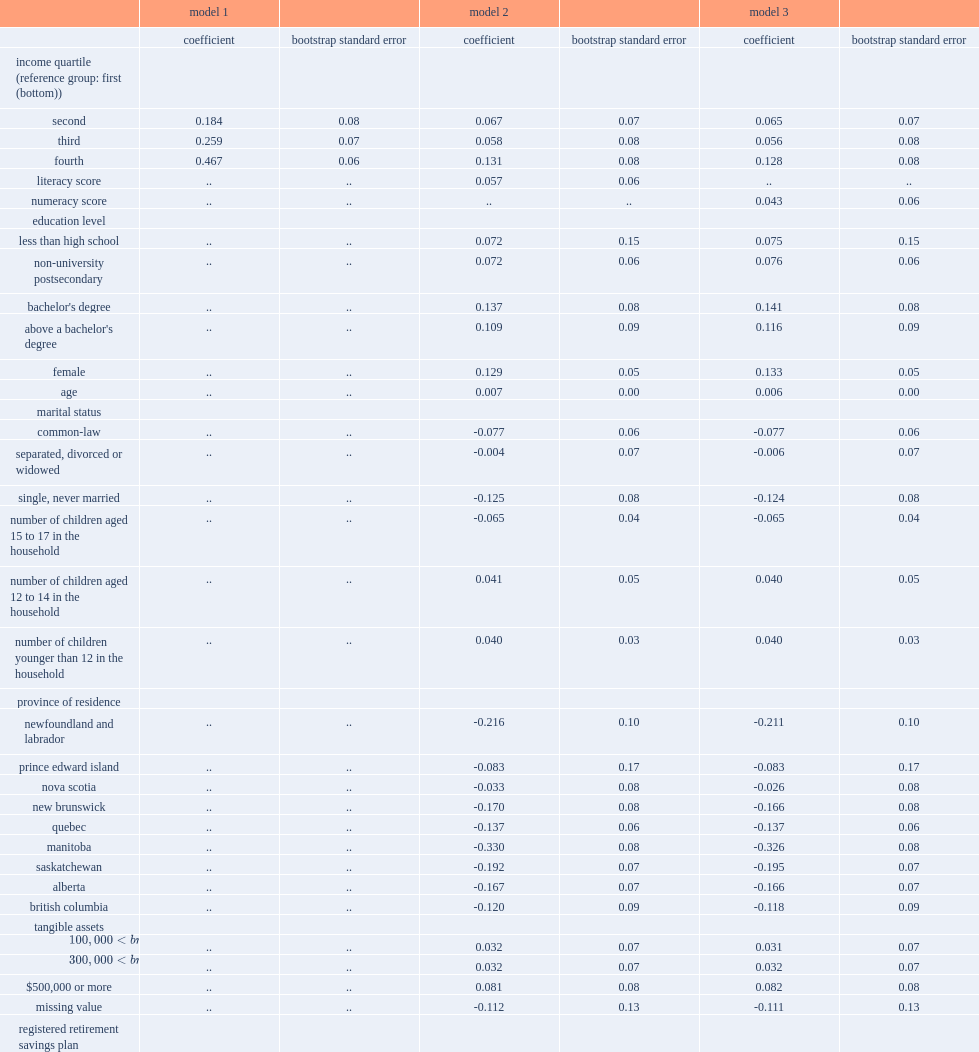In lisa, how many percentage points of the resp gap has changed from 45.1 percentage points when immigrants were removed from the sample? 0.467. 